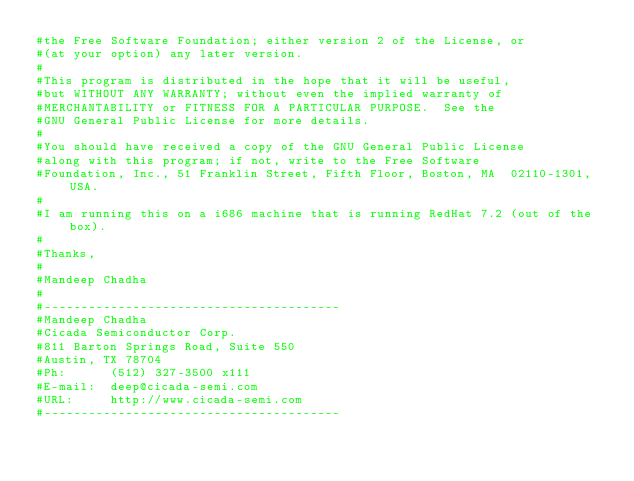Convert code to text. <code><loc_0><loc_0><loc_500><loc_500><_Awk_>#the Free Software Foundation; either version 2 of the License, or
#(at your option) any later version.
#
#This program is distributed in the hope that it will be useful,
#but WITHOUT ANY WARRANTY; without even the implied warranty of
#MERCHANTABILITY or FITNESS FOR A PARTICULAR PURPOSE.  See the
#GNU General Public License for more details.
#
#You should have received a copy of the GNU General Public License
#along with this program; if not, write to the Free Software
#Foundation, Inc., 51 Franklin Street, Fifth Floor, Boston, MA  02110-1301, USA.
#
#I am running this on a i686 machine that is running RedHat 7.2 (out of the box).
#
#Thanks,
#
#Mandeep Chadha
#
#----------------------------------------
#Mandeep Chadha
#Cicada Semiconductor Corp.
#811 Barton Springs Road, Suite 550
#Austin, TX 78704
#Ph:      (512) 327-3500 x111
#E-mail:  deep@cicada-semi.com
#URL:     http://www.cicada-semi.com
#----------------------------------------
</code> 